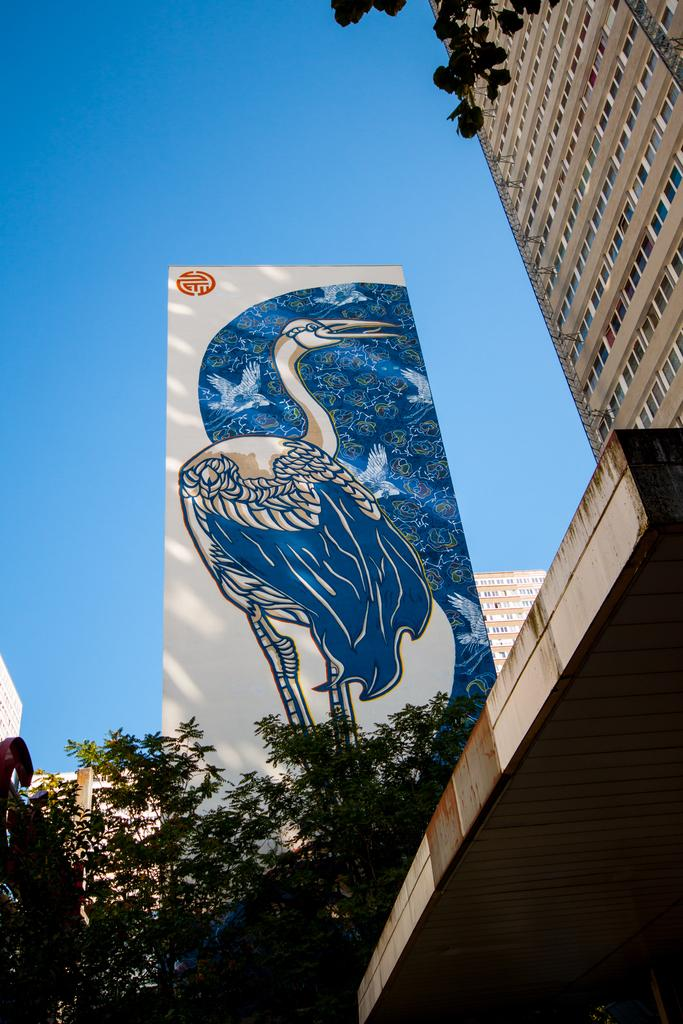What is the main object in the image? There is a board in the image. What type of natural environment is visible in the image? There are trees in the image. What type of man-made structures can be seen in the image? There are buildings in the image. What is visible in the background of the image? The sky is visible in the image. What type of plantation can be seen in the image? There is no plantation present in the image. What time of day is it in the image? The time of day cannot be determined from the image alone. 